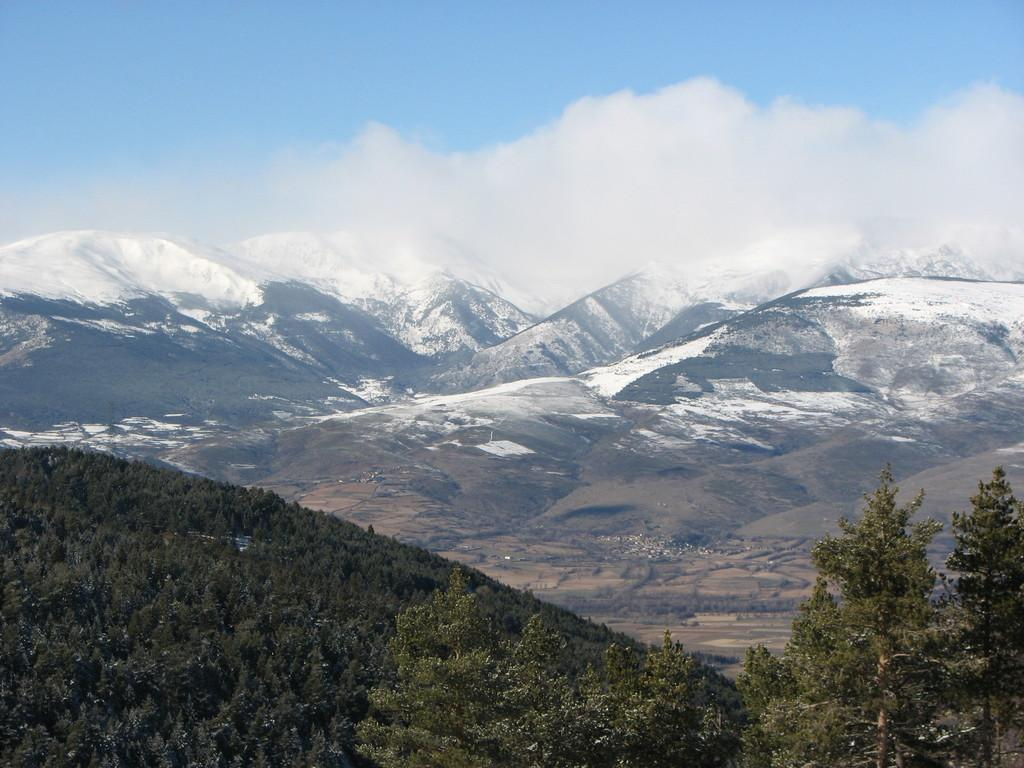What type of vegetation is in the foreground of the image? There are trees in the foreground of the image. What type of geographical feature is in the background of the image? There are mountains in the background of the image. What can be seen in the sky in the image? There are clouds visible in the sky. What type of loaf is being used to create the clouds in the image? There is no loaf present in the image, and clouds are formed by water vapor in the atmosphere, not by any type of loaf. 